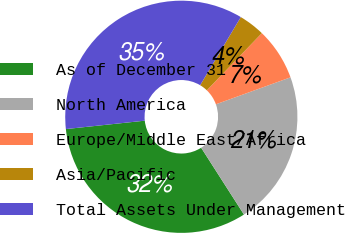Convert chart to OTSL. <chart><loc_0><loc_0><loc_500><loc_500><pie_chart><fcel>As of December 31<fcel>North America<fcel>Europe/Middle East/Africa<fcel>Asia/Pacific<fcel>Total Assets Under Management<nl><fcel>32.38%<fcel>21.45%<fcel>7.28%<fcel>3.64%<fcel>35.25%<nl></chart> 